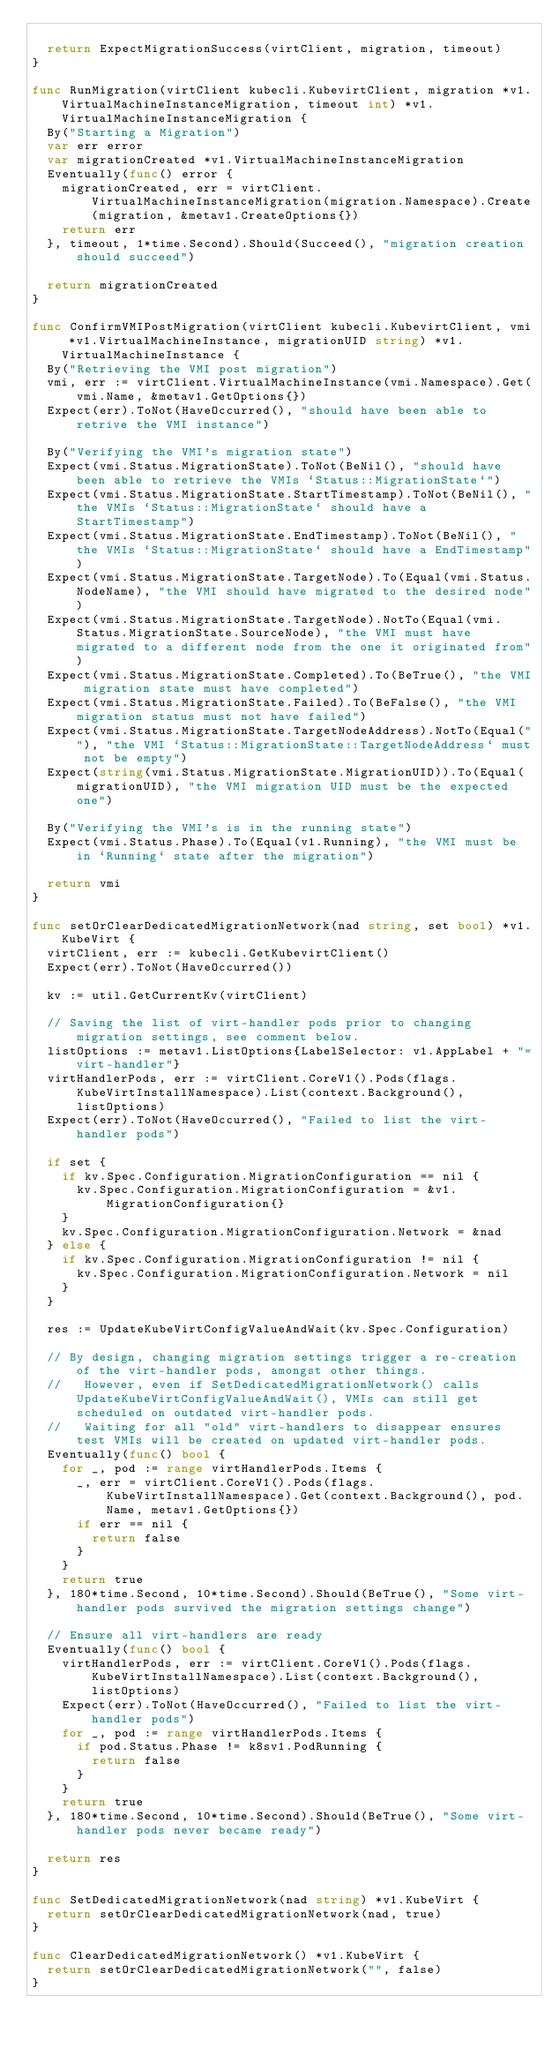Convert code to text. <code><loc_0><loc_0><loc_500><loc_500><_Go_>
	return ExpectMigrationSuccess(virtClient, migration, timeout)
}

func RunMigration(virtClient kubecli.KubevirtClient, migration *v1.VirtualMachineInstanceMigration, timeout int) *v1.VirtualMachineInstanceMigration {
	By("Starting a Migration")
	var err error
	var migrationCreated *v1.VirtualMachineInstanceMigration
	Eventually(func() error {
		migrationCreated, err = virtClient.VirtualMachineInstanceMigration(migration.Namespace).Create(migration, &metav1.CreateOptions{})
		return err
	}, timeout, 1*time.Second).Should(Succeed(), "migration creation should succeed")

	return migrationCreated
}

func ConfirmVMIPostMigration(virtClient kubecli.KubevirtClient, vmi *v1.VirtualMachineInstance, migrationUID string) *v1.VirtualMachineInstance {
	By("Retrieving the VMI post migration")
	vmi, err := virtClient.VirtualMachineInstance(vmi.Namespace).Get(vmi.Name, &metav1.GetOptions{})
	Expect(err).ToNot(HaveOccurred(), "should have been able to retrive the VMI instance")

	By("Verifying the VMI's migration state")
	Expect(vmi.Status.MigrationState).ToNot(BeNil(), "should have been able to retrieve the VMIs `Status::MigrationState`")
	Expect(vmi.Status.MigrationState.StartTimestamp).ToNot(BeNil(), "the VMIs `Status::MigrationState` should have a StartTimestamp")
	Expect(vmi.Status.MigrationState.EndTimestamp).ToNot(BeNil(), "the VMIs `Status::MigrationState` should have a EndTimestamp")
	Expect(vmi.Status.MigrationState.TargetNode).To(Equal(vmi.Status.NodeName), "the VMI should have migrated to the desired node")
	Expect(vmi.Status.MigrationState.TargetNode).NotTo(Equal(vmi.Status.MigrationState.SourceNode), "the VMI must have migrated to a different node from the one it originated from")
	Expect(vmi.Status.MigrationState.Completed).To(BeTrue(), "the VMI migration state must have completed")
	Expect(vmi.Status.MigrationState.Failed).To(BeFalse(), "the VMI migration status must not have failed")
	Expect(vmi.Status.MigrationState.TargetNodeAddress).NotTo(Equal(""), "the VMI `Status::MigrationState::TargetNodeAddress` must not be empty")
	Expect(string(vmi.Status.MigrationState.MigrationUID)).To(Equal(migrationUID), "the VMI migration UID must be the expected one")

	By("Verifying the VMI's is in the running state")
	Expect(vmi.Status.Phase).To(Equal(v1.Running), "the VMI must be in `Running` state after the migration")

	return vmi
}

func setOrClearDedicatedMigrationNetwork(nad string, set bool) *v1.KubeVirt {
	virtClient, err := kubecli.GetKubevirtClient()
	Expect(err).ToNot(HaveOccurred())

	kv := util.GetCurrentKv(virtClient)

	// Saving the list of virt-handler pods prior to changing migration settings, see comment below.
	listOptions := metav1.ListOptions{LabelSelector: v1.AppLabel + "=virt-handler"}
	virtHandlerPods, err := virtClient.CoreV1().Pods(flags.KubeVirtInstallNamespace).List(context.Background(), listOptions)
	Expect(err).ToNot(HaveOccurred(), "Failed to list the virt-handler pods")

	if set {
		if kv.Spec.Configuration.MigrationConfiguration == nil {
			kv.Spec.Configuration.MigrationConfiguration = &v1.MigrationConfiguration{}
		}
		kv.Spec.Configuration.MigrationConfiguration.Network = &nad
	} else {
		if kv.Spec.Configuration.MigrationConfiguration != nil {
			kv.Spec.Configuration.MigrationConfiguration.Network = nil
		}
	}

	res := UpdateKubeVirtConfigValueAndWait(kv.Spec.Configuration)

	// By design, changing migration settings trigger a re-creation of the virt-handler pods, amongst other things.
	//   However, even if SetDedicatedMigrationNetwork() calls UpdateKubeVirtConfigValueAndWait(), VMIs can still get scheduled on outdated virt-handler pods.
	//   Waiting for all "old" virt-handlers to disappear ensures test VMIs will be created on updated virt-handler pods.
	Eventually(func() bool {
		for _, pod := range virtHandlerPods.Items {
			_, err = virtClient.CoreV1().Pods(flags.KubeVirtInstallNamespace).Get(context.Background(), pod.Name, metav1.GetOptions{})
			if err == nil {
				return false
			}
		}
		return true
	}, 180*time.Second, 10*time.Second).Should(BeTrue(), "Some virt-handler pods survived the migration settings change")

	// Ensure all virt-handlers are ready
	Eventually(func() bool {
		virtHandlerPods, err := virtClient.CoreV1().Pods(flags.KubeVirtInstallNamespace).List(context.Background(), listOptions)
		Expect(err).ToNot(HaveOccurred(), "Failed to list the virt-handler pods")
		for _, pod := range virtHandlerPods.Items {
			if pod.Status.Phase != k8sv1.PodRunning {
				return false
			}
		}
		return true
	}, 180*time.Second, 10*time.Second).Should(BeTrue(), "Some virt-handler pods never became ready")

	return res
}

func SetDedicatedMigrationNetwork(nad string) *v1.KubeVirt {
	return setOrClearDedicatedMigrationNetwork(nad, true)
}

func ClearDedicatedMigrationNetwork() *v1.KubeVirt {
	return setOrClearDedicatedMigrationNetwork("", false)
}
</code> 